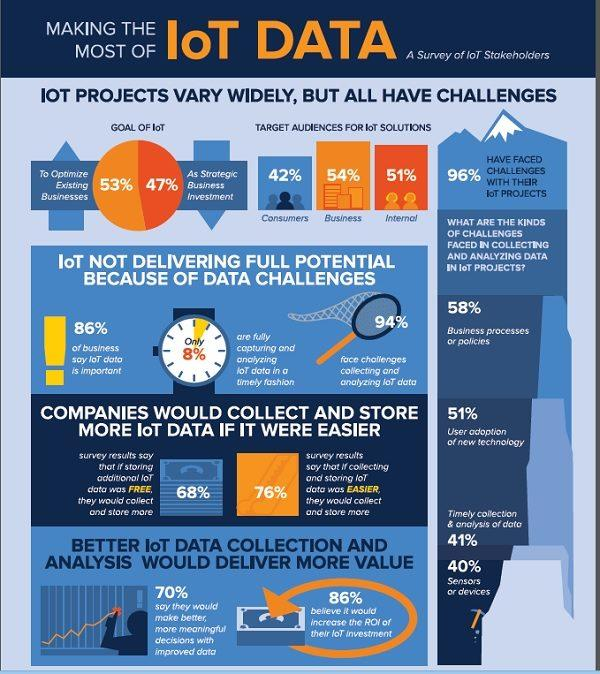Draw attention to some important aspects in this diagram. The target audience for IoT solutions with the highest number of individuals is the business sector. According to the data, 47% of IoT investments are for business purposes. Only 4% of those who have embarked on an IoT project have not faced any challenges during its execution. The major challenge in the collection and analysis of data is the business processes or policies. There are four types of challenges that are commonly faced when collecting and analyzing data in IoT projects. 